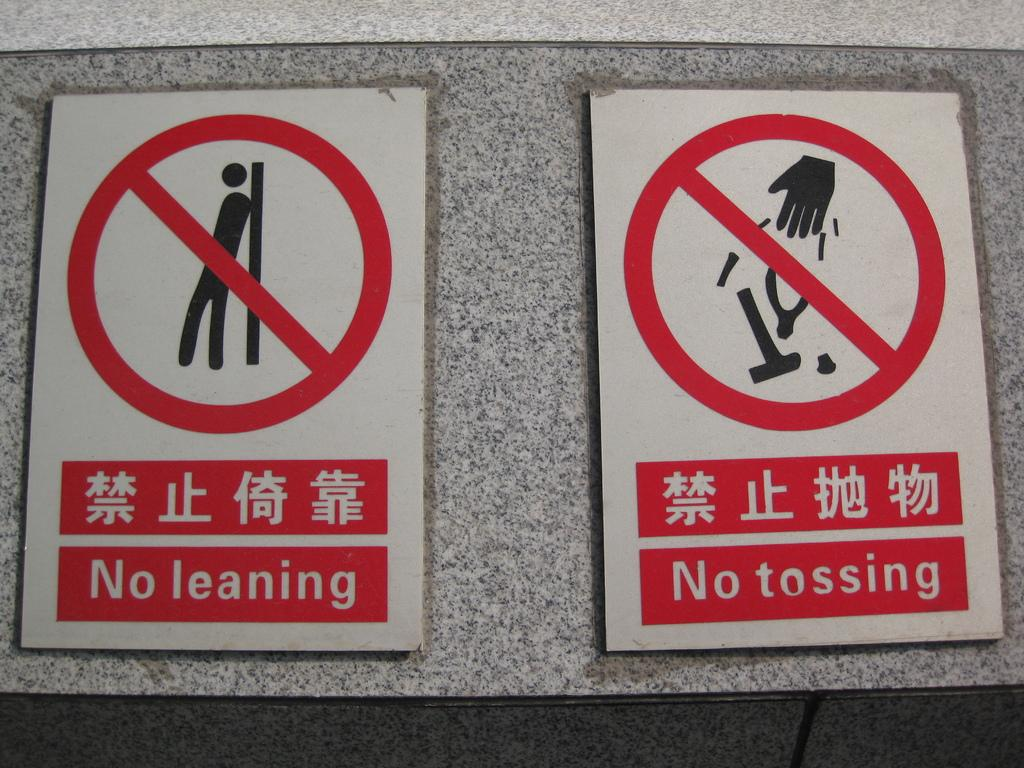What can be seen on the wall in the image? There are sign boards on the wall in the image. How many potatoes are displayed on the wall in the image? There are no potatoes displayed on the wall in the image; it features sign boards. What time of day is depicted in the image? The time of day is not visible or indicated in the image. Is there a party happening in the image? There is no indication of a party happening in the image. 